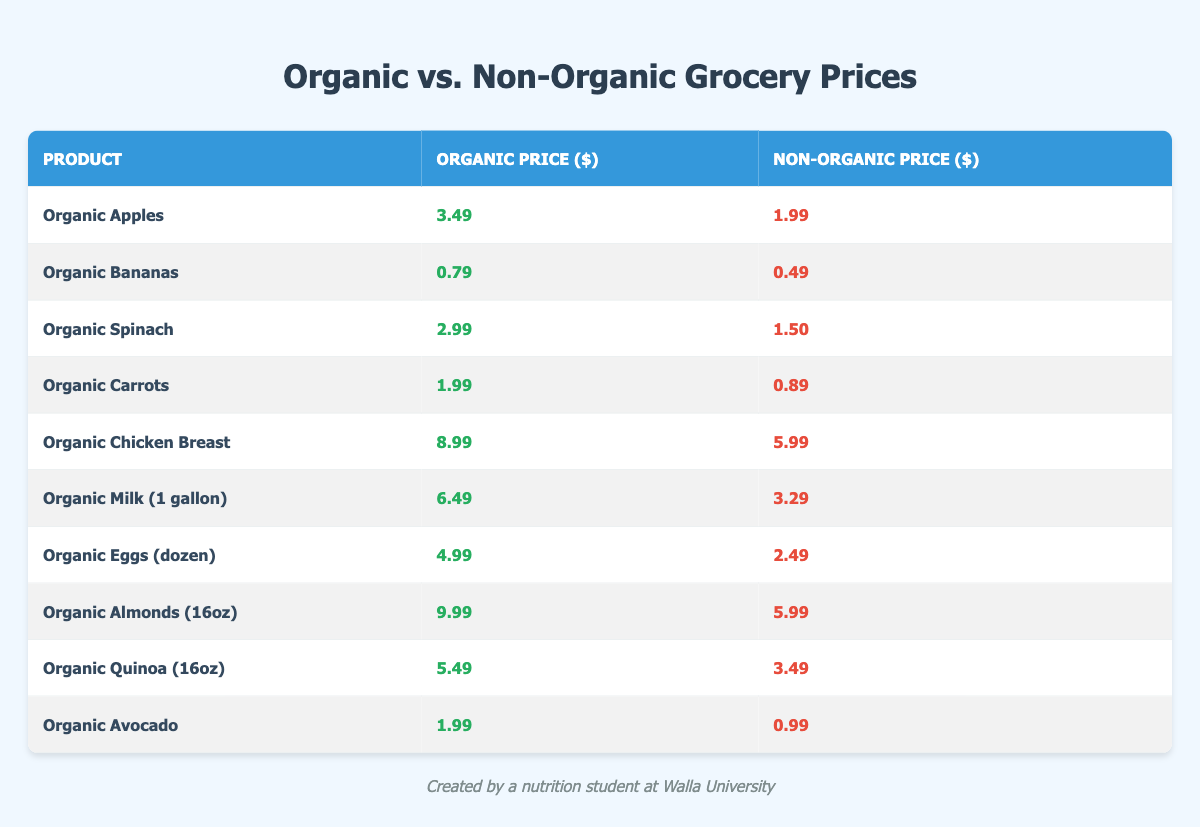What is the price of Organic Apples? The table lists Organic Apples with a price of $3.49 in the organic column.
Answer: $3.49 What is the non-organic price of Organic Bananas? The table shows that the non-organic price for Organic Bananas is $0.49.
Answer: $0.49 Which product has the highest organic price? Scanning through the organic prices in the table, Organic Almonds have the highest price at $9.99.
Answer: Organic Almonds What is the price difference between Organic Chicken Breast and its non-organic counterpart? The organic price of Chicken Breast is $8.99 and the non-organic price is $5.99. The difference is $8.99 - $5.99 = $3.00.
Answer: $3.00 What is the total cost of purchasing Organic Milk and Organic Eggs? The organic price of Milk is $6.49 and Eggs is $4.99. Adding these gives $6.49 + $4.99 = $11.48.
Answer: $11.48 Is the price of Organic Spinach more than double the price of Non-Organic Spinach? The organic price of Spinach is $2.99, and the non-organic price is $1.50. Double the non-organic price is $3.00, and since $2.99 is less than $3.00, it is not more than double.
Answer: No What is the average organic price of the fruits listed in the table (Organic Apples, Bananas, Spinach, Carrots, and Avocado)? The organic prices for these fruits are $3.49, $0.79, $2.99, $1.99, and $1.99. Summing these gives $3.49 + $0.79 + $2.99 + $1.99 + $1.99 = $12.25. With 5 products, the average is $12.25 / 5 = $2.45.
Answer: $2.45 Which product has the smallest price gap between its organic and non-organic versions? Comparing the price gaps, Organic Bananas ($0.79 - $0.49 = $0.30), Organic Avocado ($1.99 - $0.99 = $1.00), Organic Carrots ($1.99 - $0.89 = $1.10), etc. The smallest gap is $0.30 for Organic Bananas.
Answer: Organic Bananas Which product's organic price is exactly three times its non-organic price? Looking at the prices, Organic Eggs at $4.99 are three times the non-organic price of $2.49 since 3 x $2.49 = $7.47. Therefore, this is not accurate. No product meets this condition.
Answer: No What is the combined organic price of Organic Spinach and Organic Quinoa? The organic price of Spinach is $2.99 and Quinoa is $5.49. Adding these gives $2.99 + $5.49 = $8.48.
Answer: $8.48 